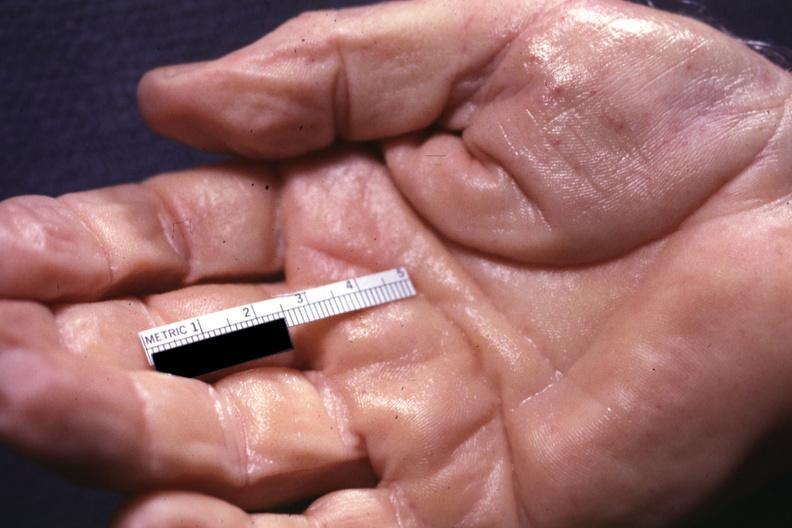what are present?
Answer the question using a single word or phrase. Extremities 